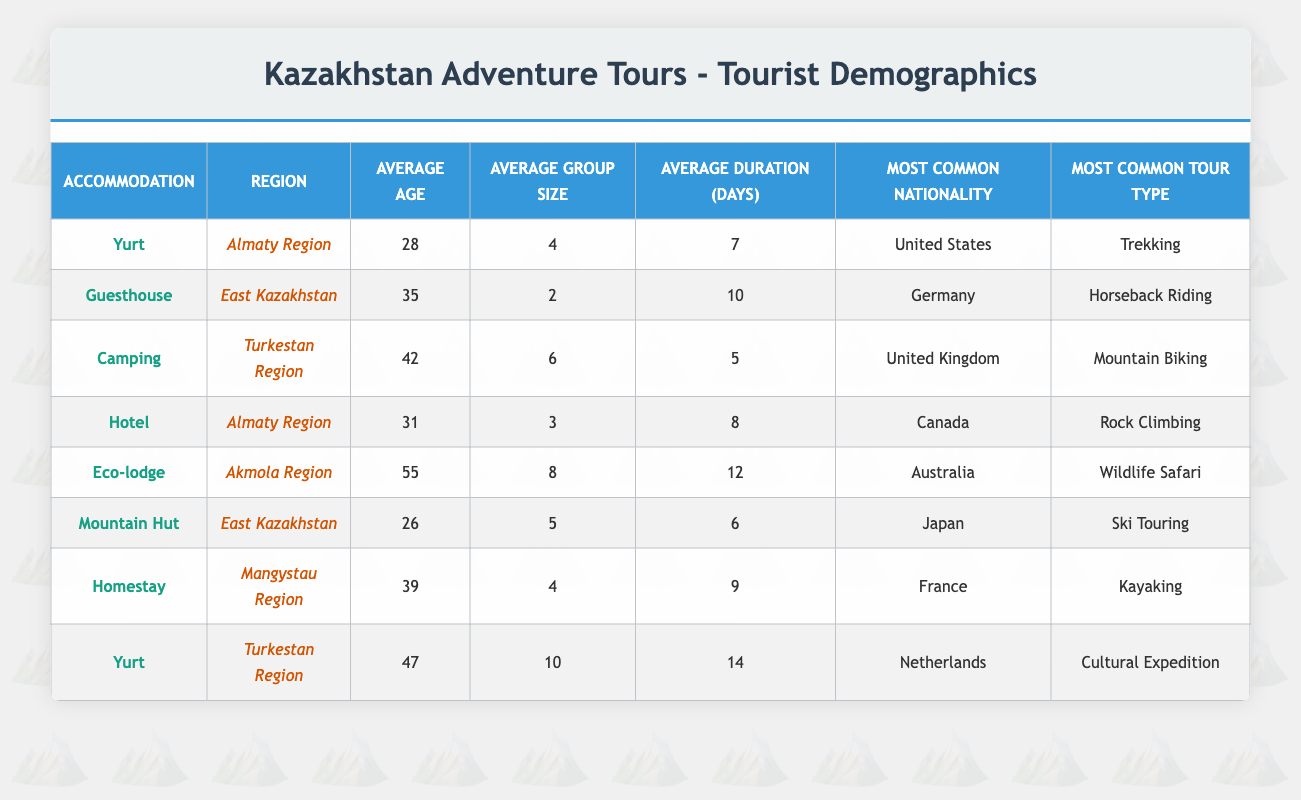What is the most common accommodation type in the Turkestan Region? The Turkestan Region has two entries in the table, one for "Camping" with 42 as the average age and "Yurt" with 47 as the average age. Since both types of accommodations are listed, the most common accommodation type is "Yurt" based on the records provided.
Answer: Yurt What is the average duration of stay for tourists who prefer Eco-lodges? The table shows that the Eco-lodge has an average duration of 12 days for tourists in the Akmola Region. There is only one entry for Eco-lodge, so the average duration is taken directly from that entry.
Answer: 12 Is the average age of tourists who stay in Yurts lower than those who stay in Hotels? The average age for those staying in Yurts is 28 years (Almaty Region) and 47 years (Turkestan Region) leading to an average of (28 + 47) / 2 = 37.5 years. For Hotels, the average age is 31 years (Almaty Region). Since 37.5 is higher than 31, the statement is false.
Answer: No What is the most common nationality among tourists who prefer Guesthouses? Looking at the table, there is one entry for Guesthouse in East Kazakhstan, where the most common nationality is Germany. Since there's only one nationality for Guesthouses, that is the answer.
Answer: Germany What is the average group size for tourists who prefer Mountain Huts? The Mountain Hut in East Kazakhstan has an average group size of 5. Since there is only one entry for this type, the value is taken directly from the table with no need for calculation.
Answer: 5 Which region has the highest average age among tourists who stayed in Yurts? There are two entries under Yurt: one in Almaty Region with an average age of 28 and the other in Turkestan Region with an average age of 47. Since 47 is greater than 28, the Turkestan Region has the highest average age for Yurt accommodation.
Answer: Turkestan Region How does the average group size for Cultural Expedition tourists compare to that of Kayaking tourists? The table shows that the average group size for those on a Cultural Expedition is 10 (Yurt in Turkestan Region) and for Kayaking, it is 4 (Homestay in Mangystau Region). Thus, the difference is 10 - 4 = 6, indicating Cultural Expedition tourists travel in larger groups.
Answer: Higher by 6 What is the average age of tourists across all regions who prefer Camping accommodations? The table lists one Camping accommodation each in Almaty (33 years) and Turkestan (42 years). To find the average across both entries: (42 + 33) / 2 = 37.5. Therefore, the average age is based on those two entries.
Answer: 37.5 